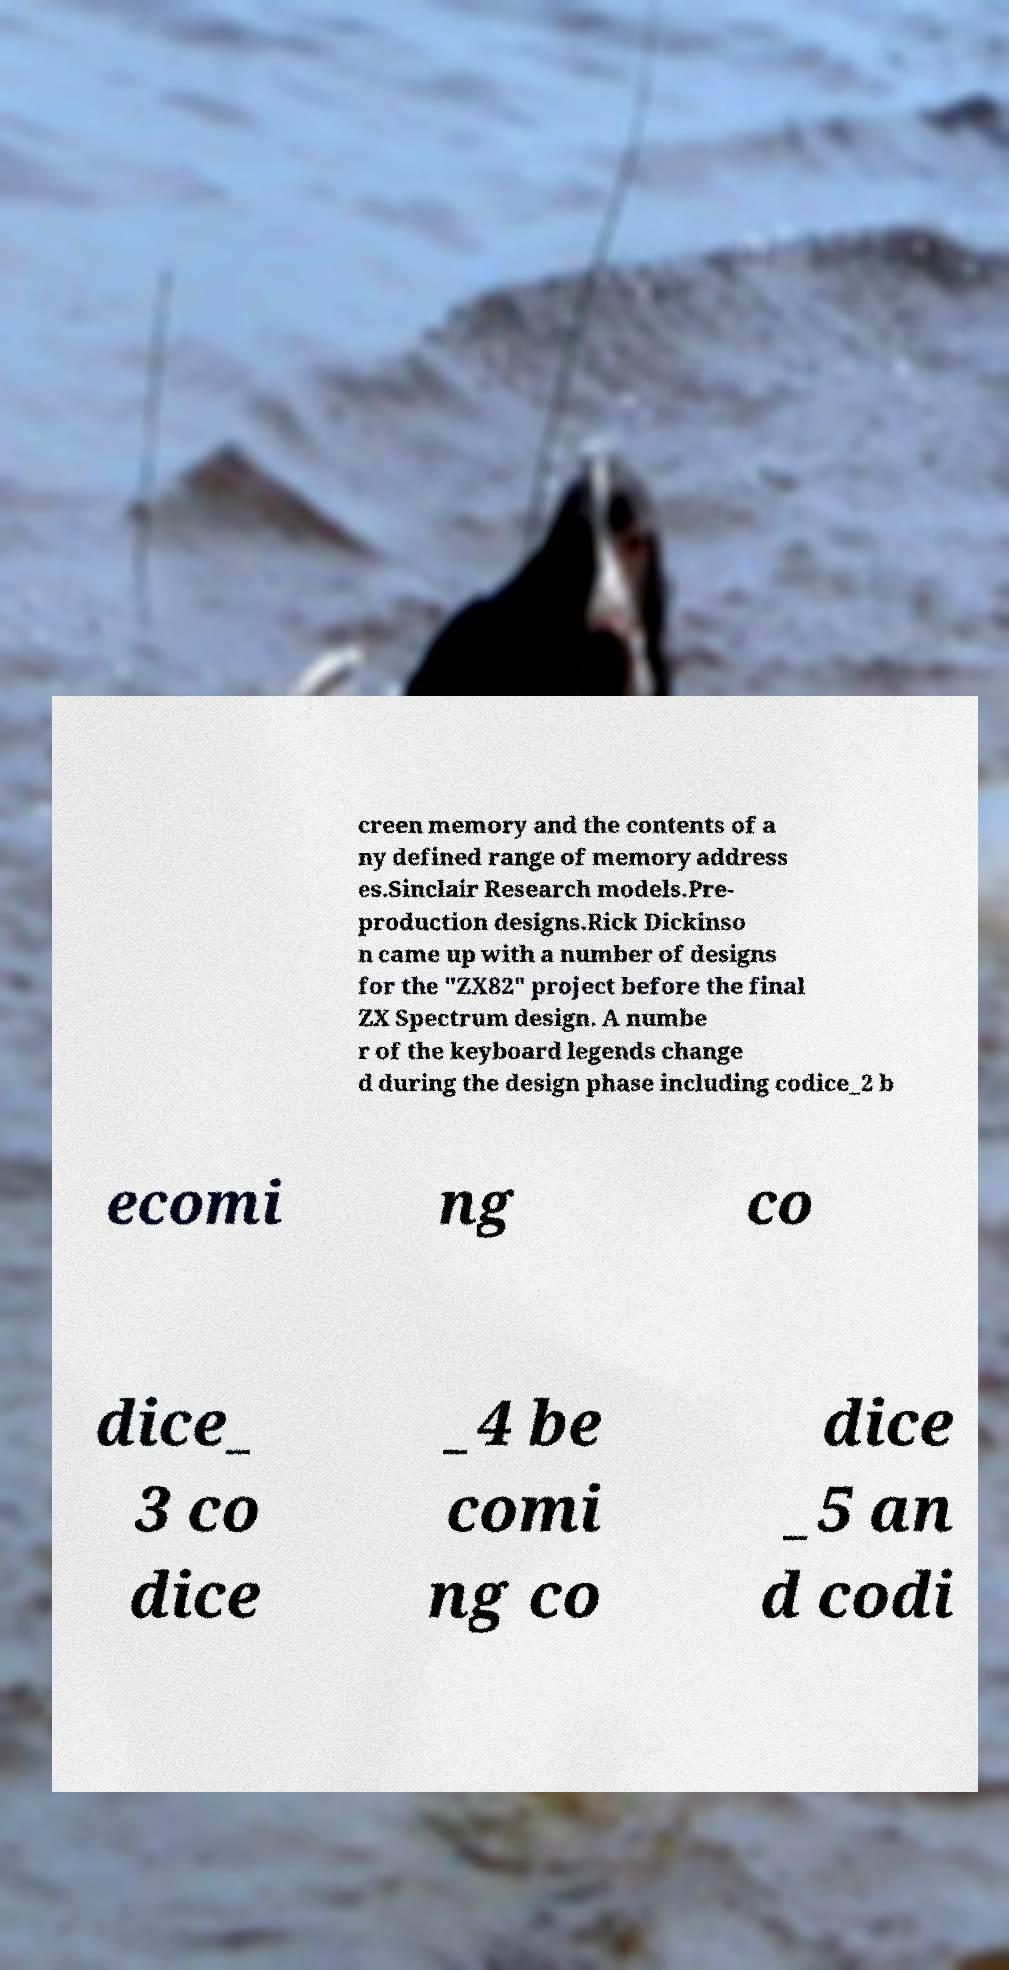For documentation purposes, I need the text within this image transcribed. Could you provide that? creen memory and the contents of a ny defined range of memory address es.Sinclair Research models.Pre- production designs.Rick Dickinso n came up with a number of designs for the "ZX82" project before the final ZX Spectrum design. A numbe r of the keyboard legends change d during the design phase including codice_2 b ecomi ng co dice_ 3 co dice _4 be comi ng co dice _5 an d codi 